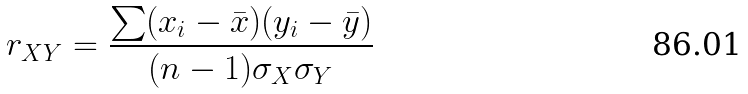Convert formula to latex. <formula><loc_0><loc_0><loc_500><loc_500>r _ { X Y } = \frac { \sum ( x _ { i } - \bar { x } ) ( y _ { i } - \bar { y } ) } { ( n - 1 ) \sigma _ { X } \sigma _ { Y } }</formula> 